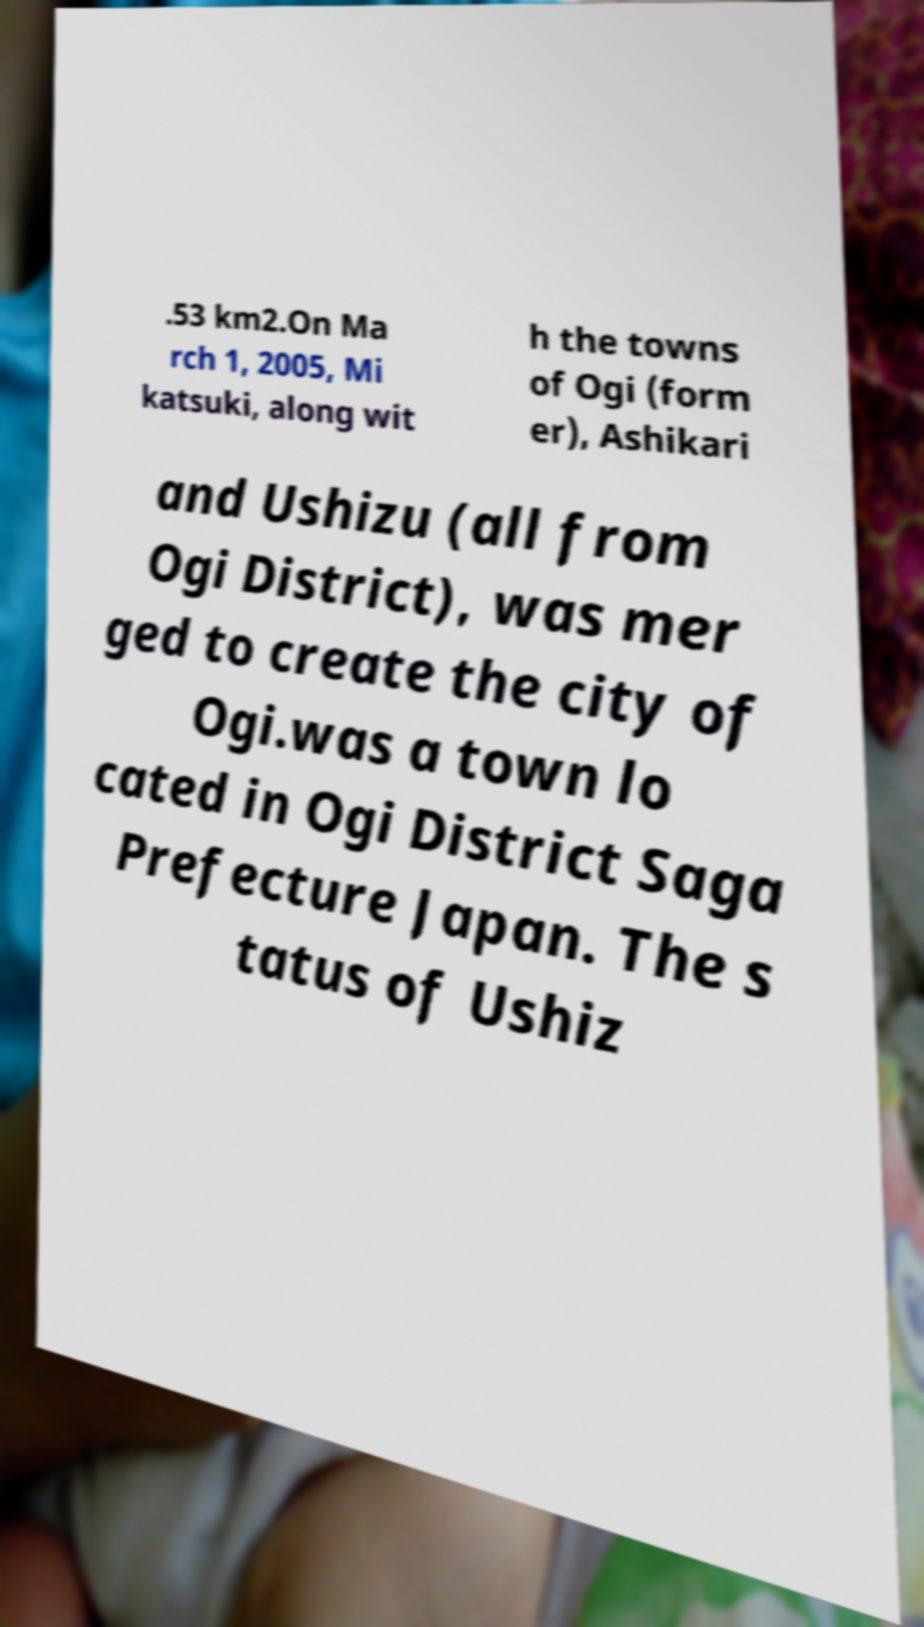Can you read and provide the text displayed in the image?This photo seems to have some interesting text. Can you extract and type it out for me? .53 km2.On Ma rch 1, 2005, Mi katsuki, along wit h the towns of Ogi (form er), Ashikari and Ushizu (all from Ogi District), was mer ged to create the city of Ogi.was a town lo cated in Ogi District Saga Prefecture Japan. The s tatus of Ushiz 